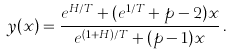<formula> <loc_0><loc_0><loc_500><loc_500>y ( x ) = \frac { e ^ { H / T } + ( e ^ { 1 / T } + p - 2 ) x } { e ^ { ( 1 + H ) / T } + ( p - 1 ) x } \, .</formula> 